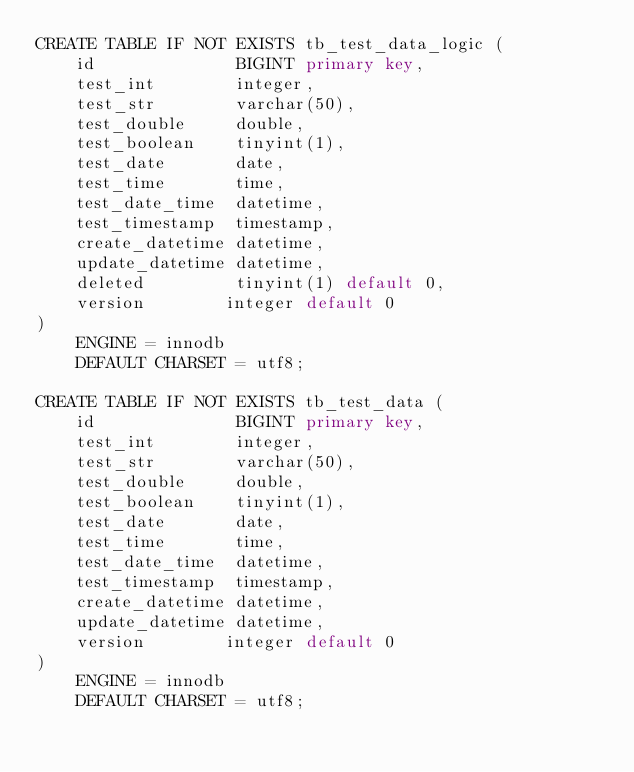<code> <loc_0><loc_0><loc_500><loc_500><_SQL_>CREATE TABLE IF NOT EXISTS tb_test_data_logic (
    id              BIGINT primary key,
    test_int        integer,
    test_str        varchar(50),
    test_double     double,
    test_boolean    tinyint(1),
    test_date       date,
    test_time       time,
    test_date_time  datetime,
    test_timestamp  timestamp,
    create_datetime datetime,
    update_datetime datetime,
    deleted         tinyint(1) default 0,
    version        integer default 0
)
    ENGINE = innodb
    DEFAULT CHARSET = utf8;

CREATE TABLE IF NOT EXISTS tb_test_data (
    id              BIGINT primary key,
    test_int        integer,
    test_str        varchar(50),
    test_double     double,
    test_boolean    tinyint(1),
    test_date       date,
    test_time       time,
    test_date_time  datetime,
    test_timestamp  timestamp,
    create_datetime datetime,
    update_datetime datetime,
    version        integer default 0
)
    ENGINE = innodb
    DEFAULT CHARSET = utf8;
</code> 